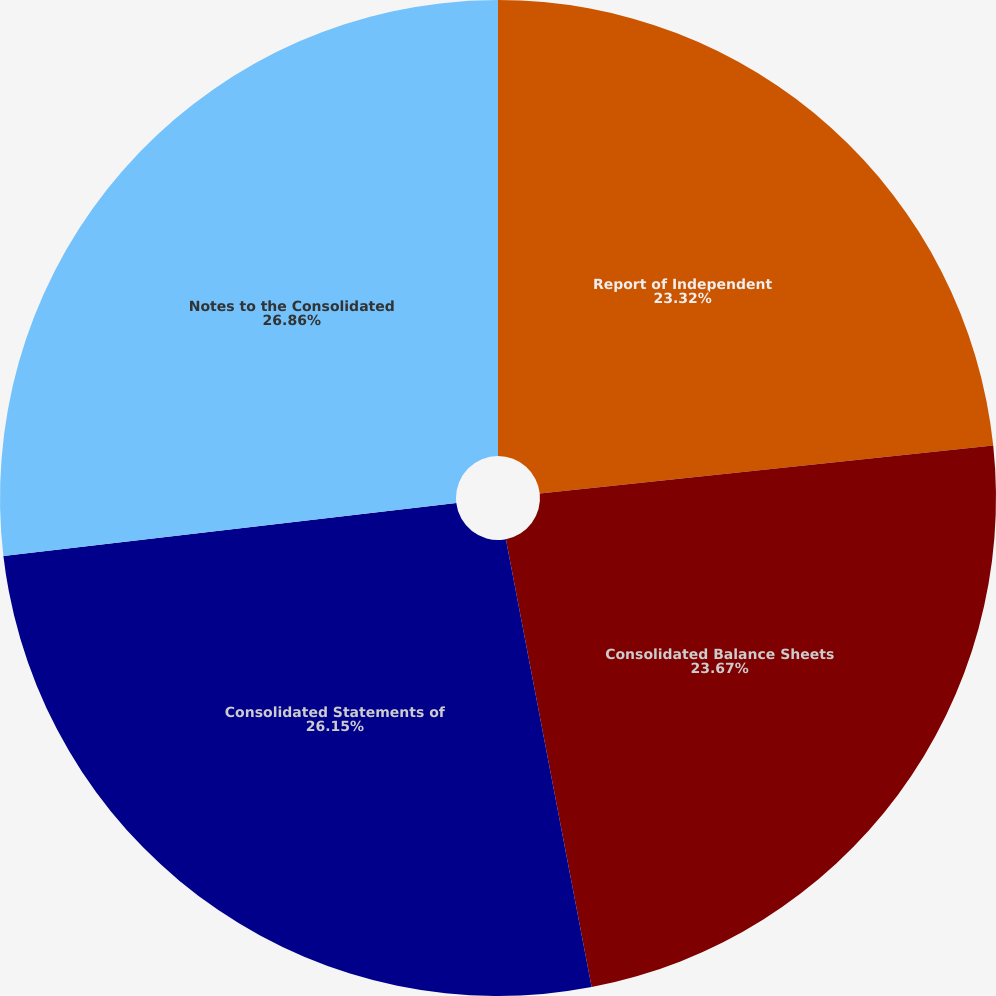<chart> <loc_0><loc_0><loc_500><loc_500><pie_chart><fcel>Report of Independent<fcel>Consolidated Balance Sheets<fcel>Consolidated Statements of<fcel>Notes to the Consolidated<nl><fcel>23.32%<fcel>23.67%<fcel>26.15%<fcel>26.86%<nl></chart> 